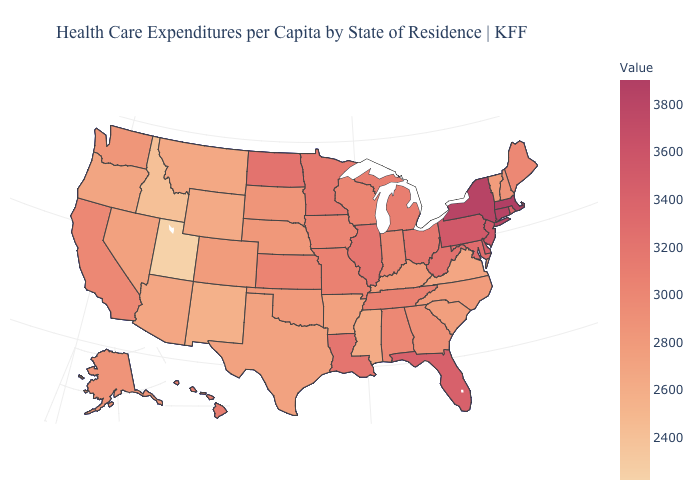Which states have the lowest value in the USA?
Give a very brief answer. Utah. Which states hav the highest value in the West?
Give a very brief answer. Hawaii. Which states hav the highest value in the South?
Give a very brief answer. Delaware. Among the states that border Nevada , which have the lowest value?
Give a very brief answer. Utah. Among the states that border New Mexico , which have the lowest value?
Keep it brief. Utah. Does California have the highest value in the West?
Short answer required. No. Does Utah have the lowest value in the USA?
Answer briefly. Yes. Among the states that border Minnesota , does Wisconsin have the highest value?
Short answer required. No. Among the states that border Nevada , which have the highest value?
Keep it brief. California. Which states hav the highest value in the Northeast?
Be succinct. Massachusetts. Which states have the lowest value in the South?
Concise answer only. Mississippi. 